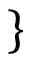<formula> <loc_0><loc_0><loc_500><loc_500>\}</formula> 